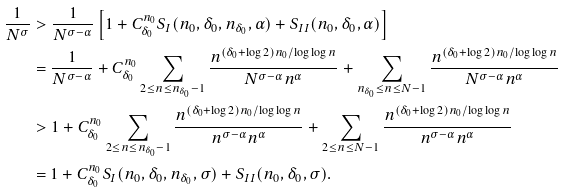Convert formula to latex. <formula><loc_0><loc_0><loc_500><loc_500>\frac { 1 } { N ^ { \sigma } } & > \frac { 1 } { N ^ { \sigma - \alpha } } \left [ 1 + C _ { \delta _ { 0 } } ^ { n _ { 0 } } S _ { I } ( n _ { 0 } , \delta _ { 0 } , n _ { \delta _ { 0 } } , \alpha ) + S _ { I I } ( n _ { 0 } , \delta _ { 0 } , \alpha ) \right ] \\ & = \frac { 1 } { N ^ { \sigma - \alpha } } + C _ { \delta _ { 0 } } ^ { n _ { 0 } } \sum _ { 2 \leq n \leq n _ { \delta _ { 0 } } - 1 } \frac { n ^ { ( \delta _ { 0 } + \log 2 ) n _ { 0 } / \log \log n } } { N ^ { \sigma - \alpha } n ^ { \alpha } } + \sum _ { n _ { \delta _ { 0 } } \leq n \leq N - 1 } \frac { n ^ { ( \delta _ { 0 } + \log 2 ) n _ { 0 } / \log \log n } } { N ^ { \sigma - \alpha } n ^ { \alpha } } \\ & > 1 + C _ { \delta _ { 0 } } ^ { n _ { 0 } } \sum _ { 2 \leq n \leq n _ { \delta _ { 0 } } - 1 } \frac { n ^ { ( \delta _ { 0 } + \log 2 ) n _ { 0 } / \log \log n } } { n ^ { \sigma - \alpha } n ^ { \alpha } } + \sum _ { 2 \leq n \leq N - 1 } \frac { n ^ { ( \delta _ { 0 } + \log 2 ) n _ { 0 } / \log \log n } } { n ^ { \sigma - \alpha } n ^ { \alpha } } \\ & = 1 + C _ { \delta _ { 0 } } ^ { n _ { 0 } } S _ { I } ( n _ { 0 } , \delta _ { 0 } , n _ { \delta _ { 0 } } , \sigma ) + S _ { I I } ( n _ { 0 } , \delta _ { 0 } , \sigma ) .</formula> 